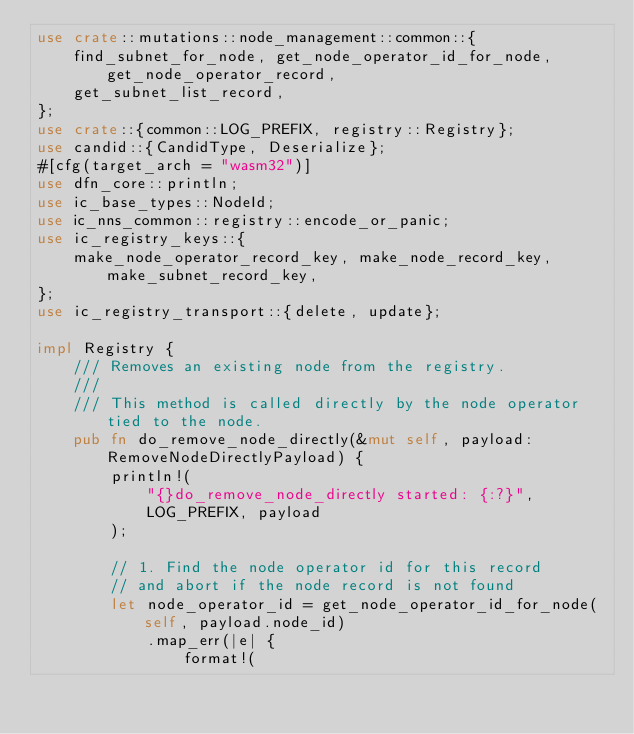<code> <loc_0><loc_0><loc_500><loc_500><_Rust_>use crate::mutations::node_management::common::{
    find_subnet_for_node, get_node_operator_id_for_node, get_node_operator_record,
    get_subnet_list_record,
};
use crate::{common::LOG_PREFIX, registry::Registry};
use candid::{CandidType, Deserialize};
#[cfg(target_arch = "wasm32")]
use dfn_core::println;
use ic_base_types::NodeId;
use ic_nns_common::registry::encode_or_panic;
use ic_registry_keys::{
    make_node_operator_record_key, make_node_record_key, make_subnet_record_key,
};
use ic_registry_transport::{delete, update};

impl Registry {
    /// Removes an existing node from the registry.
    ///
    /// This method is called directly by the node operator tied to the node.
    pub fn do_remove_node_directly(&mut self, payload: RemoveNodeDirectlyPayload) {
        println!(
            "{}do_remove_node_directly started: {:?}",
            LOG_PREFIX, payload
        );

        // 1. Find the node operator id for this record
        // and abort if the node record is not found
        let node_operator_id = get_node_operator_id_for_node(self, payload.node_id)
            .map_err(|e| {
                format!(</code> 